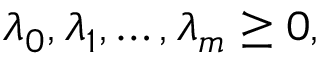<formula> <loc_0><loc_0><loc_500><loc_500>\lambda _ { 0 } , \lambda _ { 1 } , \dots , \lambda _ { m } \geq 0 ,</formula> 